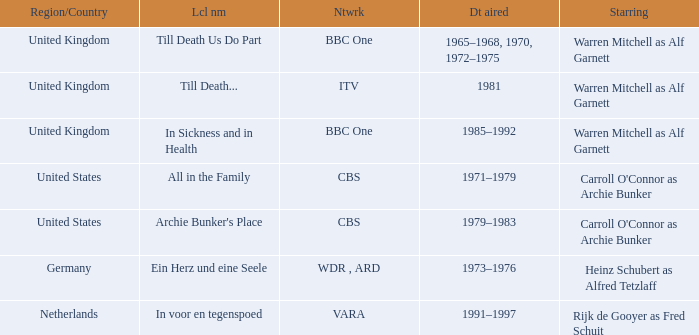What dates did the episodes air in the United States? 1971–1979, 1979–1983. 